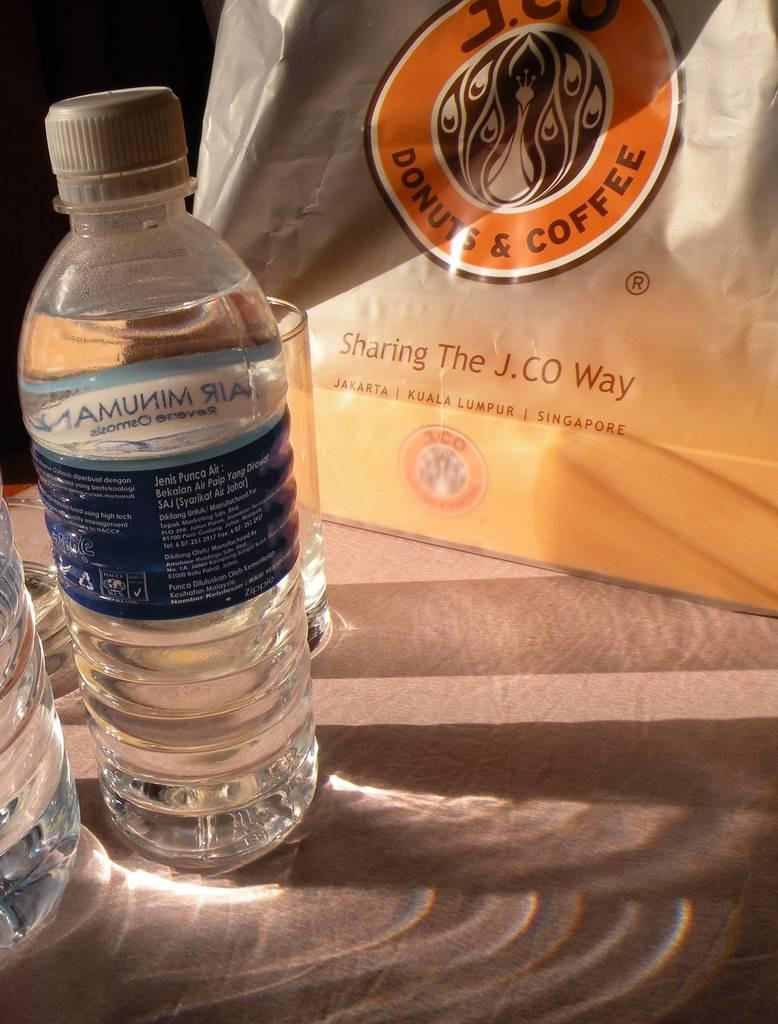<image>
Write a terse but informative summary of the picture. A bag from J.CO advertises donuts and coffee. 